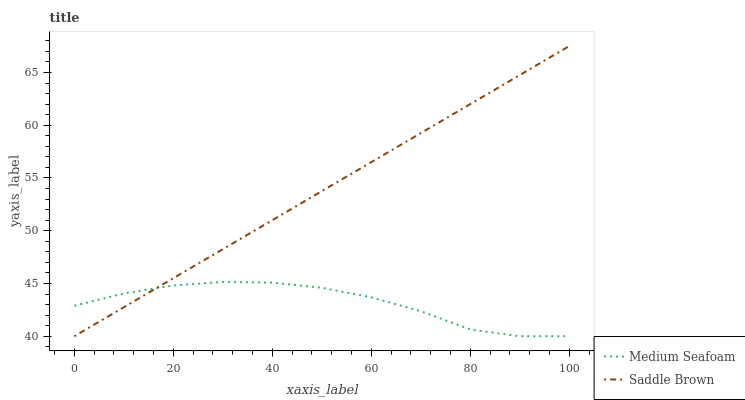Does Medium Seafoam have the minimum area under the curve?
Answer yes or no. Yes. Does Saddle Brown have the maximum area under the curve?
Answer yes or no. Yes. Does Saddle Brown have the minimum area under the curve?
Answer yes or no. No. Is Saddle Brown the smoothest?
Answer yes or no. Yes. Is Medium Seafoam the roughest?
Answer yes or no. Yes. Is Saddle Brown the roughest?
Answer yes or no. No. Does Medium Seafoam have the lowest value?
Answer yes or no. Yes. Does Saddle Brown have the highest value?
Answer yes or no. Yes. Does Saddle Brown intersect Medium Seafoam?
Answer yes or no. Yes. Is Saddle Brown less than Medium Seafoam?
Answer yes or no. No. Is Saddle Brown greater than Medium Seafoam?
Answer yes or no. No. 